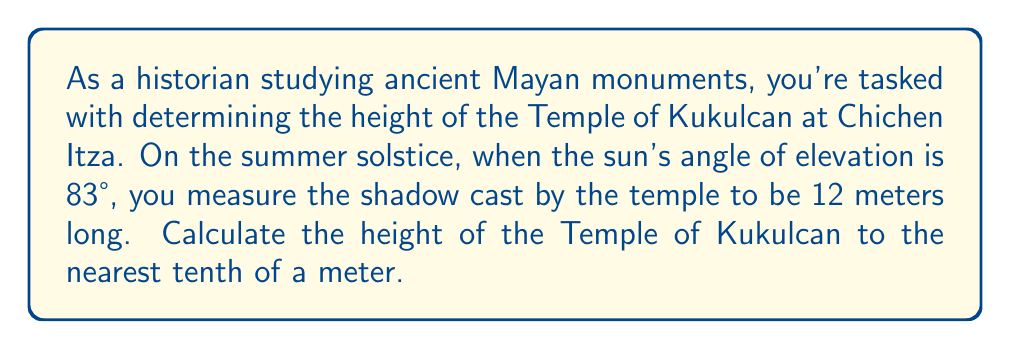Could you help me with this problem? To solve this problem, we'll use trigonometry, specifically the tangent function. Let's break it down step-by-step:

1) First, let's visualize the problem:

[asy]
import geometry;

size(200);
pair A = (0,0), B = (12,0), C = (0,50);
draw(A--B--C--A);
draw(rightangle(A,B,C,20));

label("12 m", (B/2), S);
label("h", (A--C)/2, W);
label("83°", A, SE);
label("Ground", (A--B), S);
label("Temple", (A--C), NW);
label("Shadow", (B--C), NE);
[/asy]

2) In this right triangle:
   - The adjacent side is the shadow length (12 meters)
   - The opposite side is the temple height (h)
   - The angle of elevation is 83°

3) We can use the tangent function, which is defined as:

   $$ \tan \theta = \frac{\text{opposite}}{\text{adjacent}} $$

4) Plugging in our values:

   $$ \tan 83° = \frac{h}{12} $$

5) To solve for h, we multiply both sides by 12:

   $$ 12 \tan 83° = h $$

6) Now we can calculate:
   
   $$ h = 12 \times \tan 83° $$
   $$ h \approx 12 \times 8.1443 $$
   $$ h \approx 97.7316 \text{ meters} $$

7) Rounding to the nearest tenth:

   $$ h \approx 97.7 \text{ meters} $$
Answer: The height of the Temple of Kukulcan is approximately 97.7 meters. 